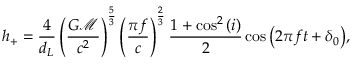<formula> <loc_0><loc_0><loc_500><loc_500>h _ { + } = \frac { 4 } { d _ { L } } \left ( \frac { G \mathcal { M } } { c ^ { 2 } } \right ) ^ { \frac { 5 } { 3 } } \left ( \frac { \pi f } { c } \right ) ^ { \frac { 2 } { 3 } } \frac { 1 + \cos ^ { 2 } { ( i ) } } { 2 } \cos { \left ( 2 \pi f t + \delta _ { 0 } \right ) } ,</formula> 